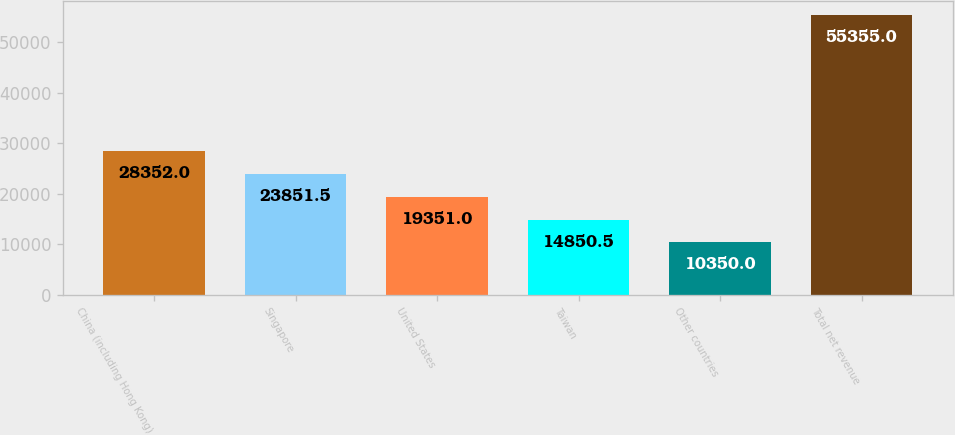<chart> <loc_0><loc_0><loc_500><loc_500><bar_chart><fcel>China (including Hong Kong)<fcel>Singapore<fcel>United States<fcel>Taiwan<fcel>Other countries<fcel>Total net revenue<nl><fcel>28352<fcel>23851.5<fcel>19351<fcel>14850.5<fcel>10350<fcel>55355<nl></chart> 